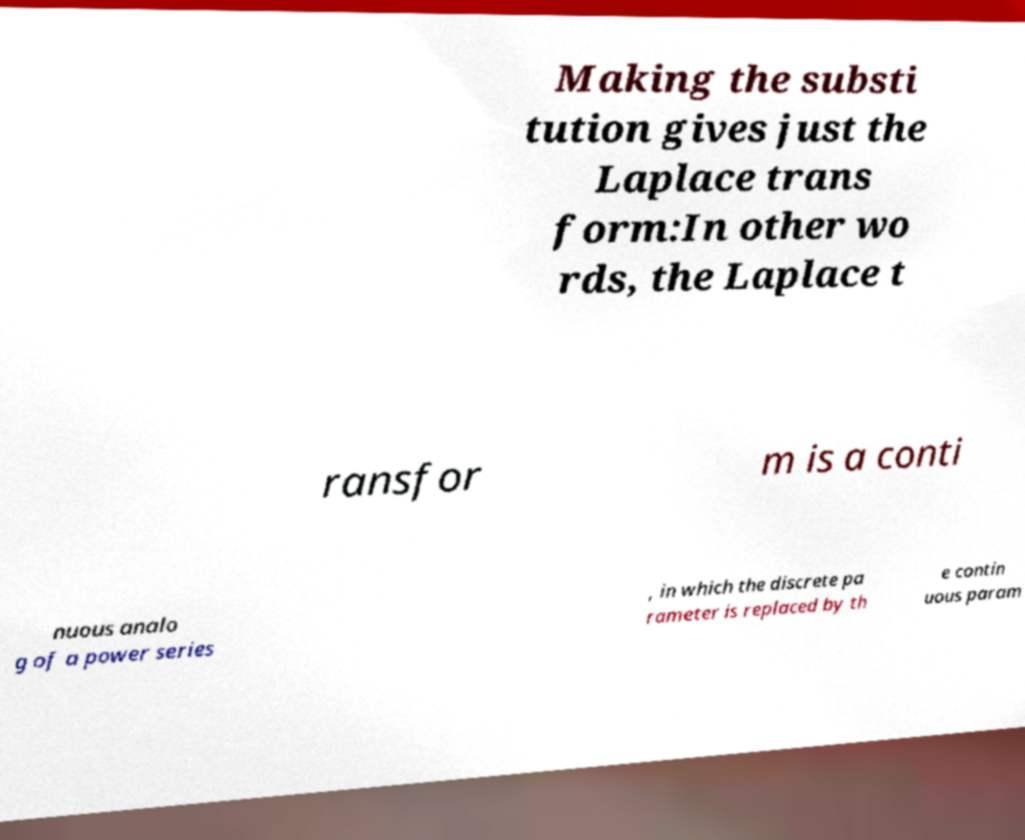Can you read and provide the text displayed in the image?This photo seems to have some interesting text. Can you extract and type it out for me? Making the substi tution gives just the Laplace trans form:In other wo rds, the Laplace t ransfor m is a conti nuous analo g of a power series , in which the discrete pa rameter is replaced by th e contin uous param 